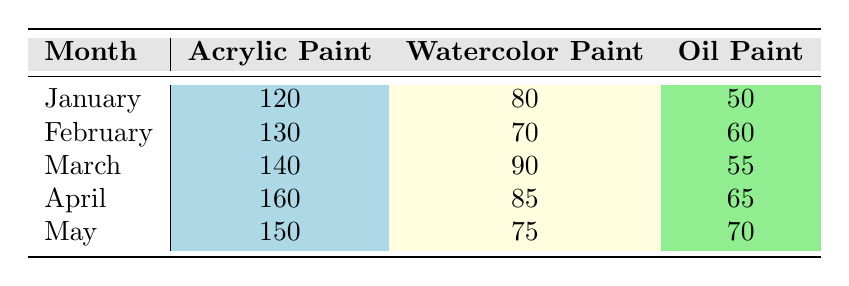What was the highest usage of Oil Paint in any month? The highest usage of Oil Paint can be found by looking at the Oil Paint column and finding the maximum value. In the table, the values are 50, 60, 55, 65, and 70 for the respective months. The highest is 70 in May.
Answer: 70 Which month had the lowest usage of Watercolor Paint? To determine the month with the lowest usage of Watercolor Paint, we compare the values in the Watercolor Paint column: 80, 70, 90, 85, and 75. The lowest of these is 70, which occurred in February.
Answer: February What is the total usage of Acrylic Paint over the five months? To find the total usage of Acrylic Paint, we sum the values from the Acrylic Paint column: 120 + 130 + 140 + 160 + 150 = 700.
Answer: 700 Is the usage of Watercolor Paint ever higher than Oil Paint in the same month? We check each month to see if Watercolor Paint usage exceeds Oil Paint usage: January (80 > 50), February (70 < 60), March (90 > 55), April (85 > 65), and May (75 < 70). In January, March, and April, Watercolor usage is higher than Oil.
Answer: Yes What is the average usage of Oil Paint across all months? To find the average usage of Oil Paint, we first compute the sum of Oil Paint usage values: 50 + 60 + 55 + 65 + 70 = 300. There are 5 months. Thus, we divide this total by 5 to get the average: 300/5 = 60.
Answer: 60 Which type of paint had the least amount used in March? In March, the usage values are 140 for Acrylic Paint, 90 for Watercolor Paint, and 55 for Oil Paint. The least amount used is 55, which is for Oil Paint.
Answer: Oil Paint What was the monthly increase in usage of Acrylic Paint from January to April? To find the monthly increase, we look at the values for Acrylic Paint: January (120), February (130), March (140), and April (160). We calculate the increases: February - January = 10, March - February = 10, and April - March = 20. The total increase from January to April is therefore 40.
Answer: 40 Did the usage of Watercolor Paint increase from March to April? In March the usage was 90, and in April it fell to 85. Since 85 is less than 90, usage did not increase.
Answer: No 